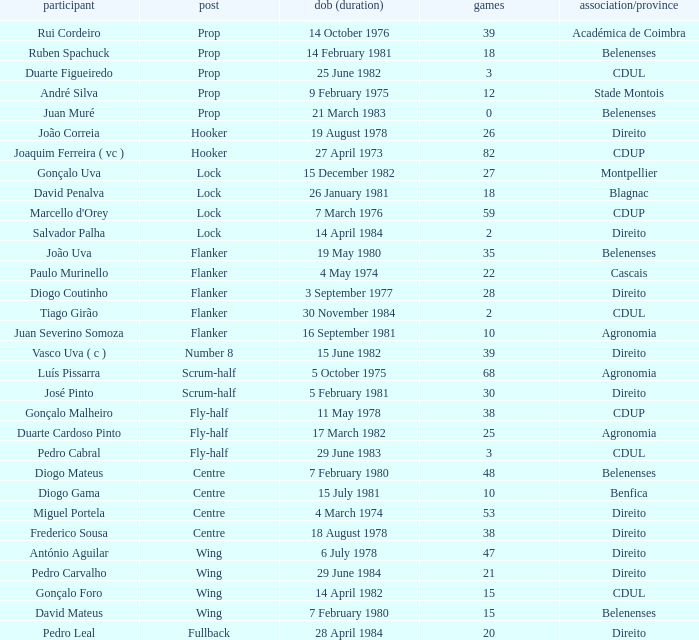Which player has a Position of fly-half, and a Caps of 3? Pedro Cabral. 